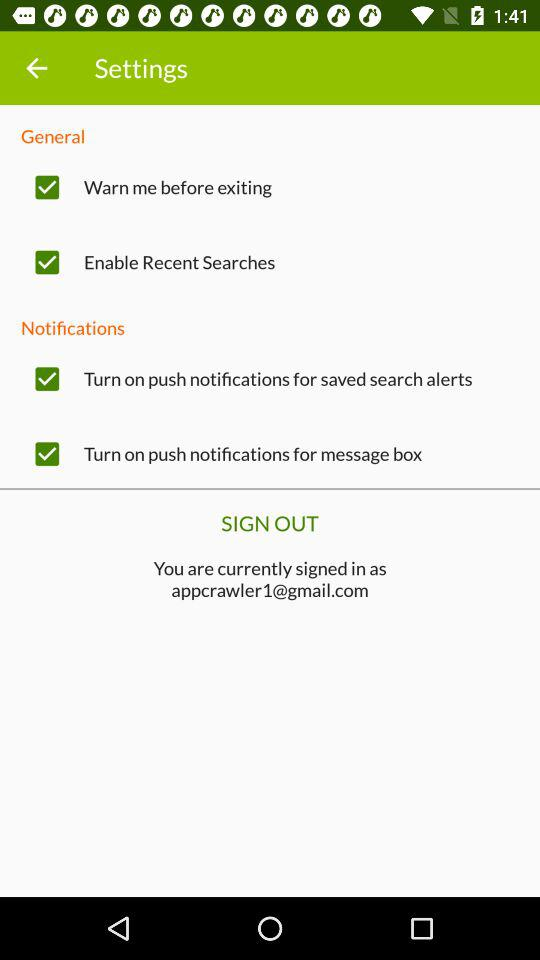How many items are there under the Notifications section?
Answer the question using a single word or phrase. 2 